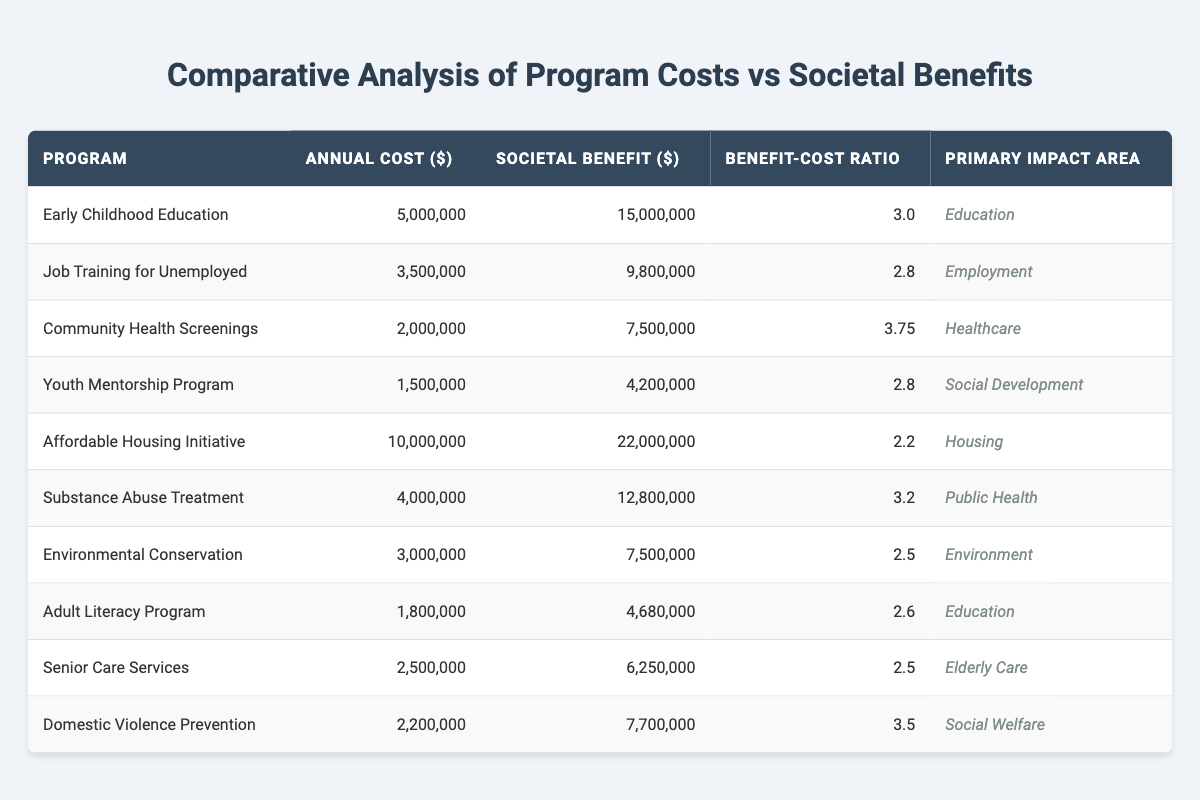What is the Benefit-Cost Ratio for the Community Health Screenings program? The Benefit-Cost Ratio for Community Health Screenings can be found in the corresponding row under the "Benefit-Cost Ratio" column, which reads 3.75.
Answer: 3.75 Which program has the highest societal benefit? By examining the "Societal Benefit ($)" column, we find that the Affordable Housing Initiative has the highest value at 22,000,000.
Answer: 22,000,000 What is the total annual cost of the Youth Mentorship Program and the Adult Literacy Program combined? The annual costs for both programs are 1,500,000 and 1,800,000 respectively. Adding these two amounts gives us 1,500,000 + 1,800,000 = 3,300,000.
Answer: 3,300,000 Is the Benefit-Cost Ratio for Substance Abuse Treatment greater than the ratio for Affordable Housing Initiative? The Benefit-Cost Ratio for Substance Abuse Treatment is 3.2 and for Affordable Housing Initiative is 2.2. Since 3.2 is greater than 2.2, the statement is true.
Answer: Yes What is the average Benefit-Cost Ratio for all programs focused on Education? The Benefit-Cost Ratios for the Education programs (Early Childhood Education and Adult Literacy Program) are 3.0 and 2.6 respectively. To find the average, we add them (3.0 + 2.6 = 5.6) and divide by 2, giving us an average of 5.6 / 2 = 2.8.
Answer: 2.8 Which program has the lowest annual cost, and what is that cost? The program with the lowest annual cost is the Youth Mentorship Program with a cost of 1,500,000 as indicated in the "Annual Cost ($)" column.
Answer: 1,500,000 What is the total societal benefit for programs in the Healthcare impact area? The total societal benefit for the Healthcare programs consists of the Community Health Screenings (7,500,000) and Substance Abuse Treatment (12,800,000). Adding these gives us 7,500,000 + 12,800,000 = 20,300,000.
Answer: 20,300,000 Does the Domestic Violence Prevention program provide a societal benefit greater than 8,000,000? The societal benefit for the Domestic Violence Prevention program is 7,700,000, which is not greater than 8,000,000. Therefore, the statement is false.
Answer: No Which impact area has the highest average Benefit-Cost Ratio? To find the average Benefit-Cost Ratio for each impact area, we will sum the ratios within each area and divide by the number of programs in each area. For example, in Education, the ratio is (3.0 + 2.6)/2 = 2.8; for Employment, it's 2.8; for Healthcare, it's (3.75 + 3.2)/2 = 3.475. Continuing this for each area, we find that Healthcare has the highest average ratio of 3.475.
Answer: Healthcare 